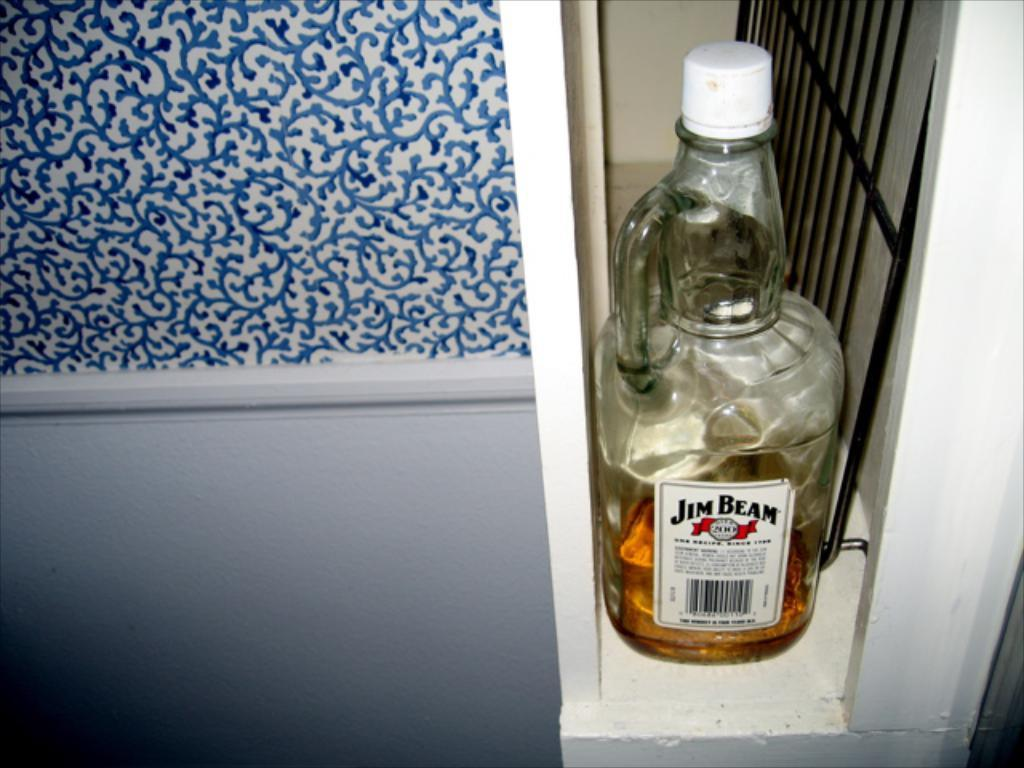What object can be seen in the picture with a sticker on it? There is a bottle in the picture, and it has a sticker on it. What else is present in the picture besides the bottle? There is a grill in the picture. What type of floor can be seen in the picture? There is no floor visible in the picture; it only shows a bottle with a sticker on it and a grill. 